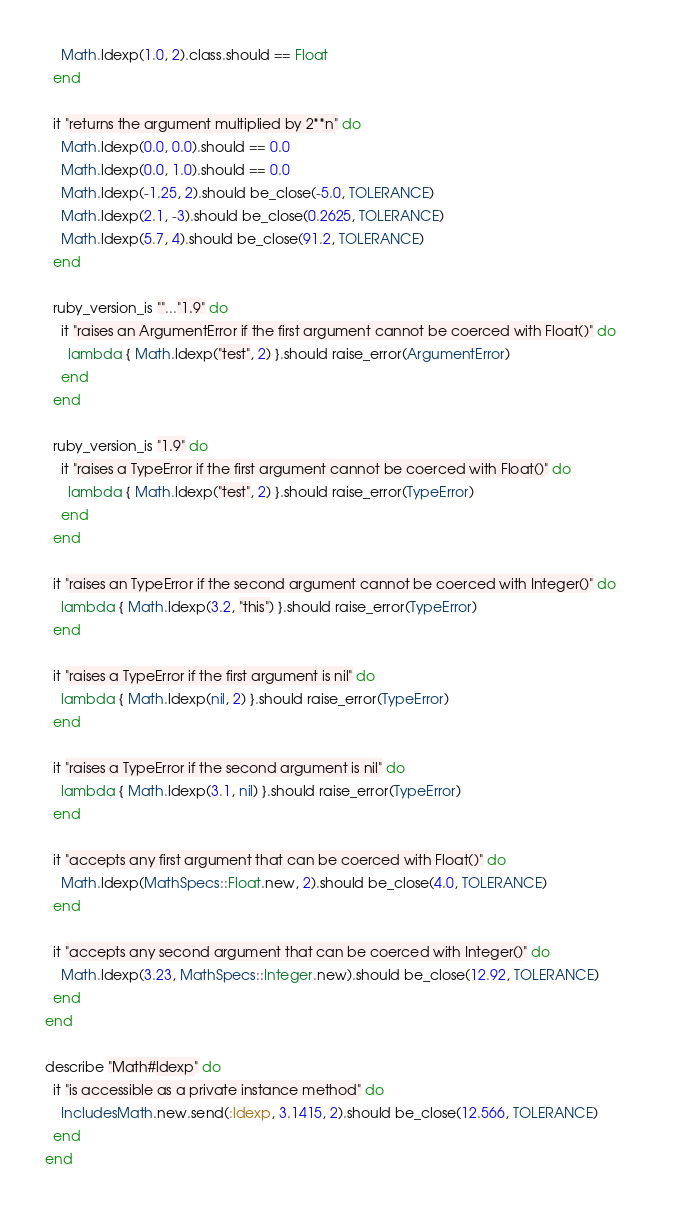<code> <loc_0><loc_0><loc_500><loc_500><_Ruby_>    Math.ldexp(1.0, 2).class.should == Float
  end
  
  it "returns the argument multiplied by 2**n" do
    Math.ldexp(0.0, 0.0).should == 0.0
    Math.ldexp(0.0, 1.0).should == 0.0
    Math.ldexp(-1.25, 2).should be_close(-5.0, TOLERANCE)
    Math.ldexp(2.1, -3).should be_close(0.2625, TOLERANCE)
    Math.ldexp(5.7, 4).should be_close(91.2, TOLERANCE)
  end

  ruby_version_is ""..."1.9" do
    it "raises an ArgumentError if the first argument cannot be coerced with Float()" do    
      lambda { Math.ldexp("test", 2) }.should raise_error(ArgumentError)
    end
  end
  
  ruby_version_is "1.9" do
    it "raises a TypeError if the first argument cannot be coerced with Float()" do    
      lambda { Math.ldexp("test", 2) }.should raise_error(TypeError)
    end
  end

  it "raises an TypeError if the second argument cannot be coerced with Integer()" do
    lambda { Math.ldexp(3.2, "this") }.should raise_error(TypeError)
  end
  
  it "raises a TypeError if the first argument is nil" do
    lambda { Math.ldexp(nil, 2) }.should raise_error(TypeError)
  end
  
  it "raises a TypeError if the second argument is nil" do
    lambda { Math.ldexp(3.1, nil) }.should raise_error(TypeError)
  end
  
  it "accepts any first argument that can be coerced with Float()" do
    Math.ldexp(MathSpecs::Float.new, 2).should be_close(4.0, TOLERANCE)
  end
  
  it "accepts any second argument that can be coerced with Integer()" do
    Math.ldexp(3.23, MathSpecs::Integer.new).should be_close(12.92, TOLERANCE)
  end
end

describe "Math#ldexp" do
  it "is accessible as a private instance method" do
    IncludesMath.new.send(:ldexp, 3.1415, 2).should be_close(12.566, TOLERANCE)
  end
end
</code> 